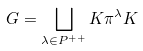<formula> <loc_0><loc_0><loc_500><loc_500>G = \bigsqcup _ { \lambda \in P ^ { + + } } K \pi ^ { \lambda } K</formula> 